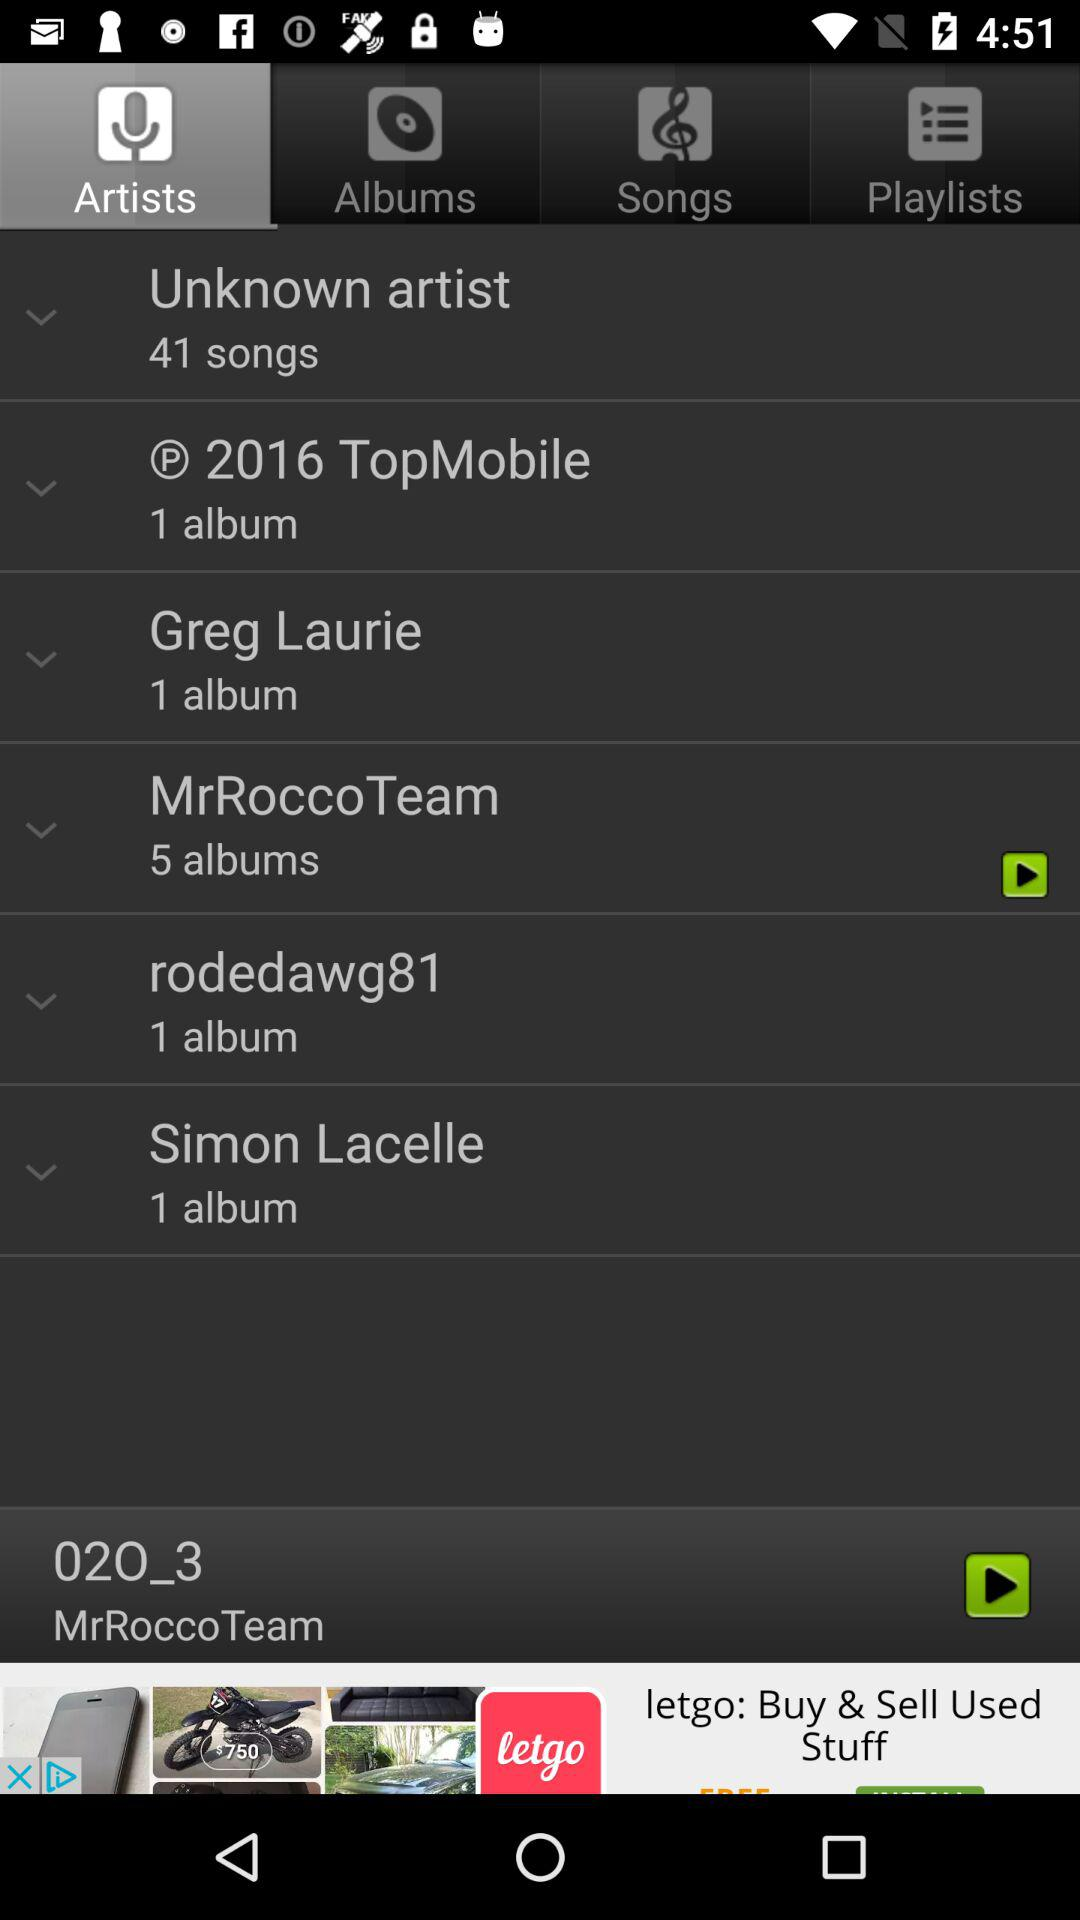Which tab has been selected? The selected tab is "Artists". 